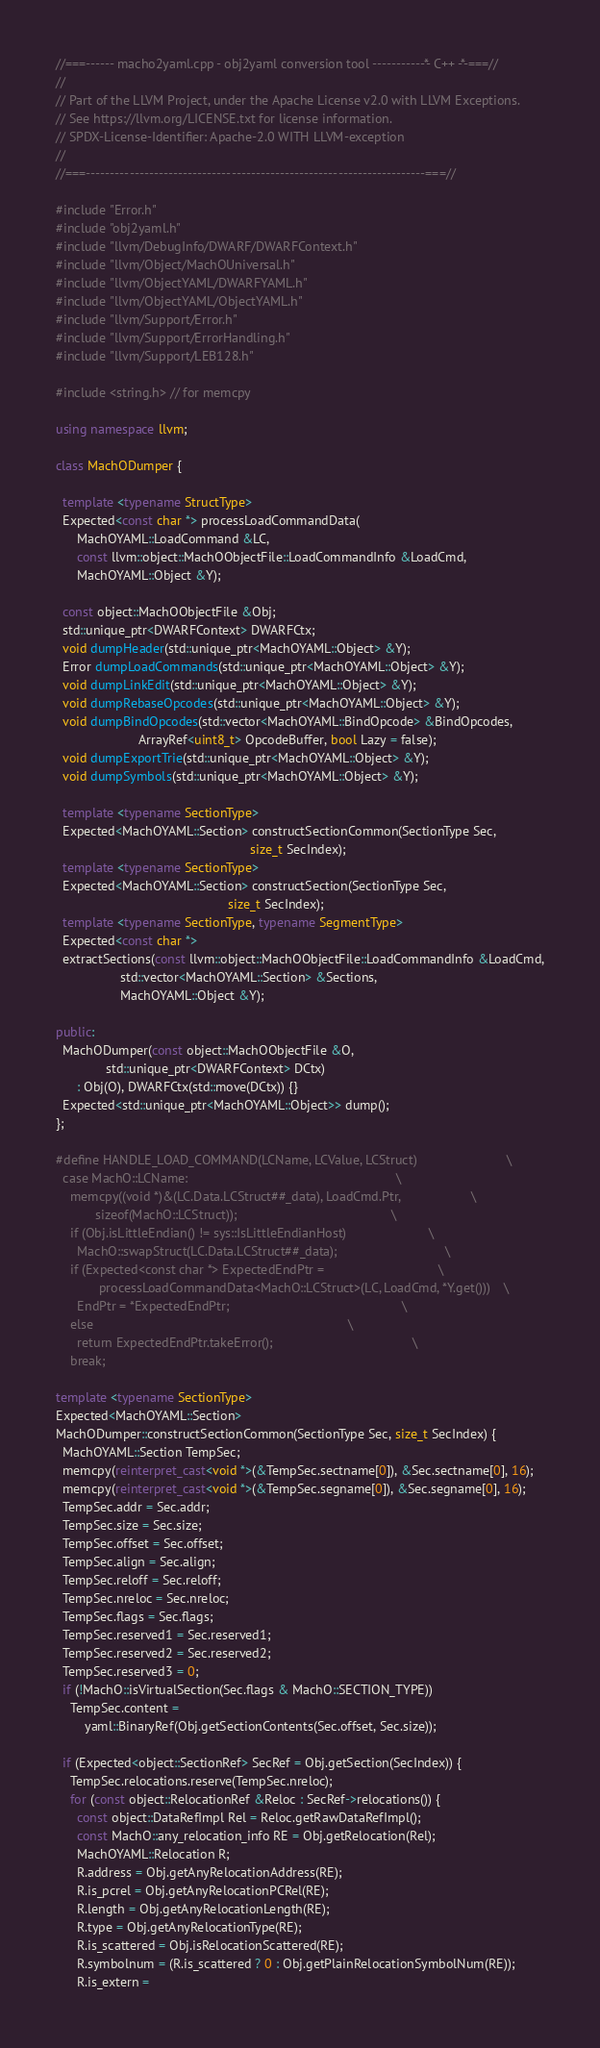<code> <loc_0><loc_0><loc_500><loc_500><_C++_>//===------ macho2yaml.cpp - obj2yaml conversion tool -----------*- C++ -*-===//
//
// Part of the LLVM Project, under the Apache License v2.0 with LLVM Exceptions.
// See https://llvm.org/LICENSE.txt for license information.
// SPDX-License-Identifier: Apache-2.0 WITH LLVM-exception
//
//===----------------------------------------------------------------------===//

#include "Error.h"
#include "obj2yaml.h"
#include "llvm/DebugInfo/DWARF/DWARFContext.h"
#include "llvm/Object/MachOUniversal.h"
#include "llvm/ObjectYAML/DWARFYAML.h"
#include "llvm/ObjectYAML/ObjectYAML.h"
#include "llvm/Support/Error.h"
#include "llvm/Support/ErrorHandling.h"
#include "llvm/Support/LEB128.h"

#include <string.h> // for memcpy

using namespace llvm;

class MachODumper {

  template <typename StructType>
  Expected<const char *> processLoadCommandData(
      MachOYAML::LoadCommand &LC,
      const llvm::object::MachOObjectFile::LoadCommandInfo &LoadCmd,
      MachOYAML::Object &Y);

  const object::MachOObjectFile &Obj;
  std::unique_ptr<DWARFContext> DWARFCtx;
  void dumpHeader(std::unique_ptr<MachOYAML::Object> &Y);
  Error dumpLoadCommands(std::unique_ptr<MachOYAML::Object> &Y);
  void dumpLinkEdit(std::unique_ptr<MachOYAML::Object> &Y);
  void dumpRebaseOpcodes(std::unique_ptr<MachOYAML::Object> &Y);
  void dumpBindOpcodes(std::vector<MachOYAML::BindOpcode> &BindOpcodes,
                       ArrayRef<uint8_t> OpcodeBuffer, bool Lazy = false);
  void dumpExportTrie(std::unique_ptr<MachOYAML::Object> &Y);
  void dumpSymbols(std::unique_ptr<MachOYAML::Object> &Y);

  template <typename SectionType>
  Expected<MachOYAML::Section> constructSectionCommon(SectionType Sec,
                                                      size_t SecIndex);
  template <typename SectionType>
  Expected<MachOYAML::Section> constructSection(SectionType Sec,
                                                size_t SecIndex);
  template <typename SectionType, typename SegmentType>
  Expected<const char *>
  extractSections(const llvm::object::MachOObjectFile::LoadCommandInfo &LoadCmd,
                  std::vector<MachOYAML::Section> &Sections,
                  MachOYAML::Object &Y);

public:
  MachODumper(const object::MachOObjectFile &O,
              std::unique_ptr<DWARFContext> DCtx)
      : Obj(O), DWARFCtx(std::move(DCtx)) {}
  Expected<std::unique_ptr<MachOYAML::Object>> dump();
};

#define HANDLE_LOAD_COMMAND(LCName, LCValue, LCStruct)                         \
  case MachO::LCName:                                                          \
    memcpy((void *)&(LC.Data.LCStruct##_data), LoadCmd.Ptr,                    \
           sizeof(MachO::LCStruct));                                           \
    if (Obj.isLittleEndian() != sys::IsLittleEndianHost)                       \
      MachO::swapStruct(LC.Data.LCStruct##_data);                              \
    if (Expected<const char *> ExpectedEndPtr =                                \
            processLoadCommandData<MachO::LCStruct>(LC, LoadCmd, *Y.get()))    \
      EndPtr = *ExpectedEndPtr;                                                \
    else                                                                       \
      return ExpectedEndPtr.takeError();                                       \
    break;

template <typename SectionType>
Expected<MachOYAML::Section>
MachODumper::constructSectionCommon(SectionType Sec, size_t SecIndex) {
  MachOYAML::Section TempSec;
  memcpy(reinterpret_cast<void *>(&TempSec.sectname[0]), &Sec.sectname[0], 16);
  memcpy(reinterpret_cast<void *>(&TempSec.segname[0]), &Sec.segname[0], 16);
  TempSec.addr = Sec.addr;
  TempSec.size = Sec.size;
  TempSec.offset = Sec.offset;
  TempSec.align = Sec.align;
  TempSec.reloff = Sec.reloff;
  TempSec.nreloc = Sec.nreloc;
  TempSec.flags = Sec.flags;
  TempSec.reserved1 = Sec.reserved1;
  TempSec.reserved2 = Sec.reserved2;
  TempSec.reserved3 = 0;
  if (!MachO::isVirtualSection(Sec.flags & MachO::SECTION_TYPE))
    TempSec.content =
        yaml::BinaryRef(Obj.getSectionContents(Sec.offset, Sec.size));

  if (Expected<object::SectionRef> SecRef = Obj.getSection(SecIndex)) {
    TempSec.relocations.reserve(TempSec.nreloc);
    for (const object::RelocationRef &Reloc : SecRef->relocations()) {
      const object::DataRefImpl Rel = Reloc.getRawDataRefImpl();
      const MachO::any_relocation_info RE = Obj.getRelocation(Rel);
      MachOYAML::Relocation R;
      R.address = Obj.getAnyRelocationAddress(RE);
      R.is_pcrel = Obj.getAnyRelocationPCRel(RE);
      R.length = Obj.getAnyRelocationLength(RE);
      R.type = Obj.getAnyRelocationType(RE);
      R.is_scattered = Obj.isRelocationScattered(RE);
      R.symbolnum = (R.is_scattered ? 0 : Obj.getPlainRelocationSymbolNum(RE));
      R.is_extern =</code> 